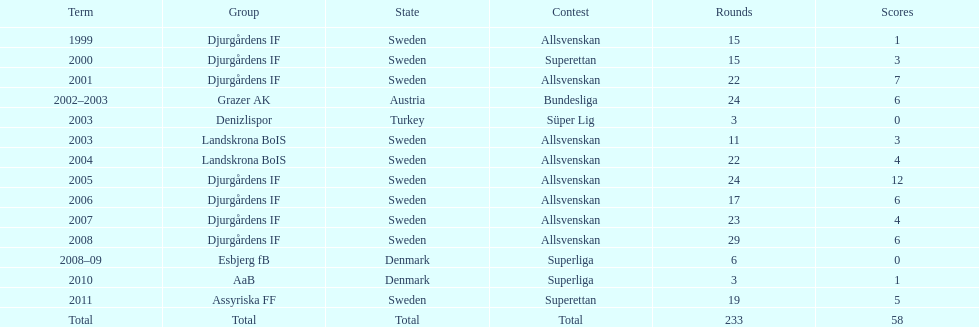How many teams had above 20 matches in the season? 6. 